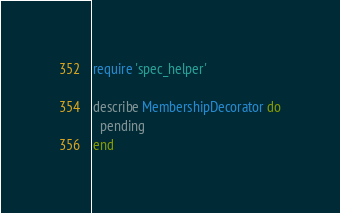Convert code to text. <code><loc_0><loc_0><loc_500><loc_500><_Ruby_>require 'spec_helper'

describe MembershipDecorator do
  pending
end
</code> 